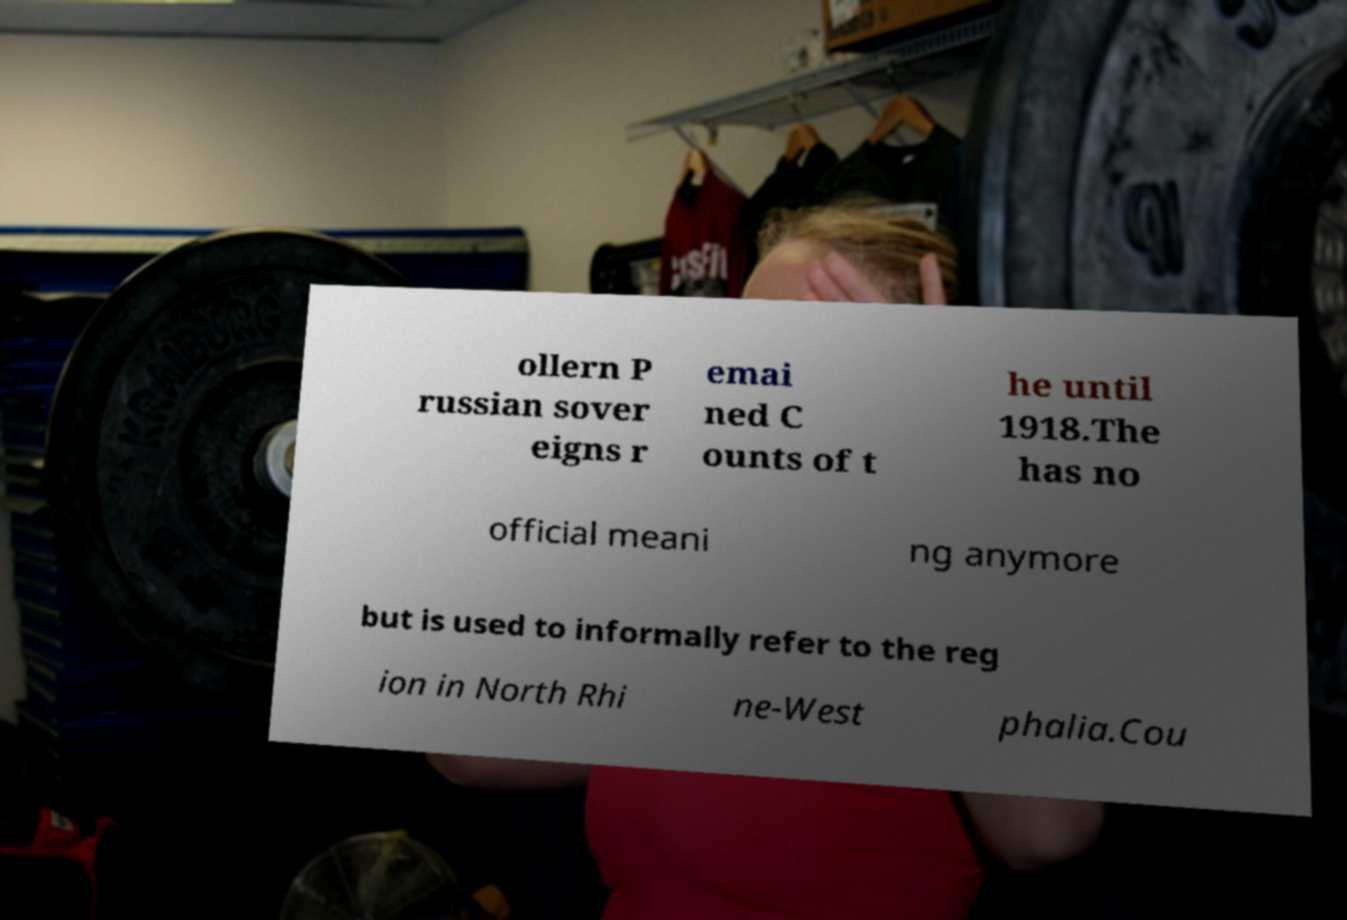Could you extract and type out the text from this image? ollern P russian sover eigns r emai ned C ounts of t he until 1918.The has no official meani ng anymore but is used to informally refer to the reg ion in North Rhi ne-West phalia.Cou 